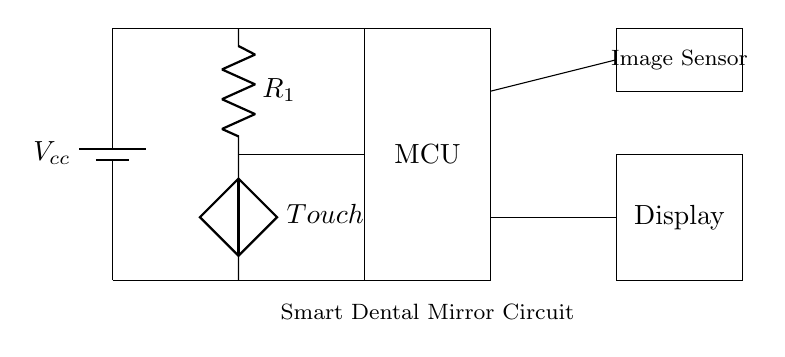What is the main component that captures images? The Image Sensor is the primary component responsible for capturing images in the circuit. It is indicated in the circuit diagram by a labeled rectangle.
Answer: Image Sensor What does the touch sensor control? The touch sensor controls the operation of the microcontroller, allowing the circuit to trigger actions when the touch is detected. The connection from the touch sensor leads to the MCU, indicating this behavior.
Answer: Microcontroller What is the power supply voltage denoted as? The power supply voltage is denoted as Vcc, which is indicated near the battery in the circuit diagram.
Answer: Vcc How many main components are displayed in this circuit? There are four main components displayed: a battery, a touch sensor, a microcontroller, and an image sensor with a display. Counting each distinct rectangle and component confirms this.
Answer: Four What is the purpose of resistor R1 in this circuit? The resistor R1 is used to limit the current in the touch sensor circuit, ensuring that the sensor operates within its safe limits when engaged. Resistors typically manage current flow, which is essential for the functionality of touch sensors.
Answer: Limit current What type of display is used in this circuit? The display used in this circuit is a simple output display designed to show the captured images from the image sensor. It is represented by a rectangle labeled "Display."
Answer: Display What is the connection type between the microcontroller and the image sensor? The microcontroller is connected to the image sensor through a direct line, indicating a clear, probable data transfer relationship for image processing. This establishes a pathway for communication between these components.
Answer: Direct connection 